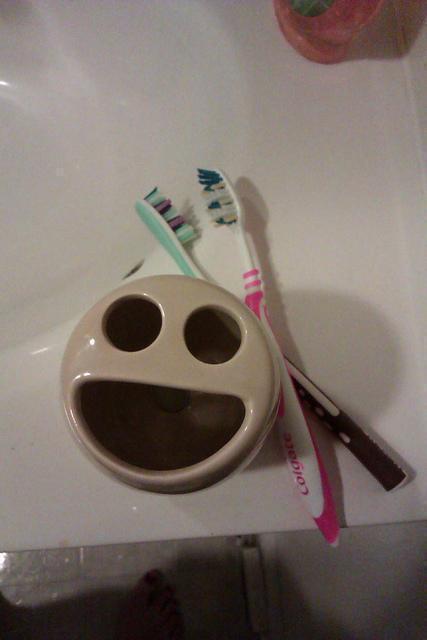What is the purpose of the cup?
Indicate the correct choice and explain in the format: 'Answer: answer
Rationale: rationale.'
Options: Carry drinks, is novelty, carry toothbrushes, child's drink. Answer: is novelty.
Rationale: It has holes to hold the tools used to brush teeth. 